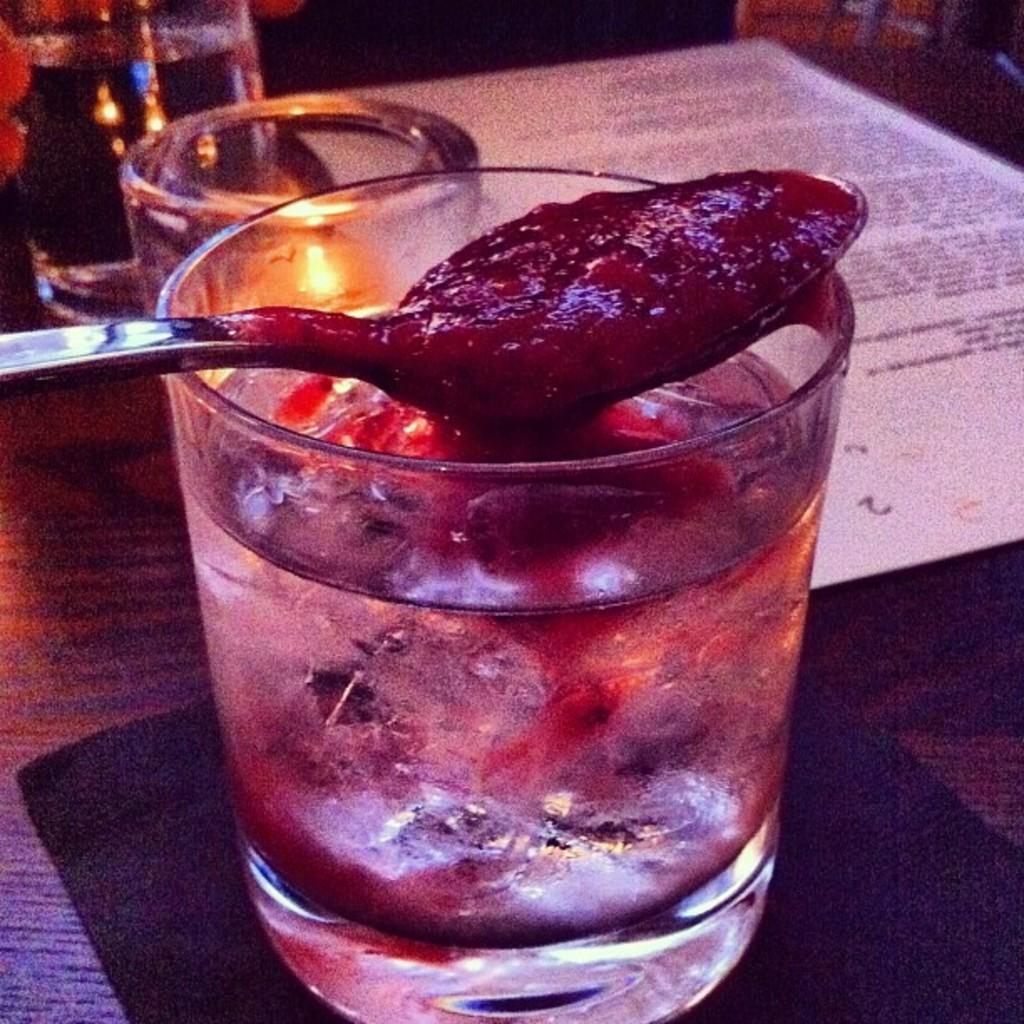In one or two sentences, can you explain what this image depicts? In this picture we can see glasses with water in it, mat, paper, spoon with food and some objects and these all are placed on a surface and in the background it is dark. 